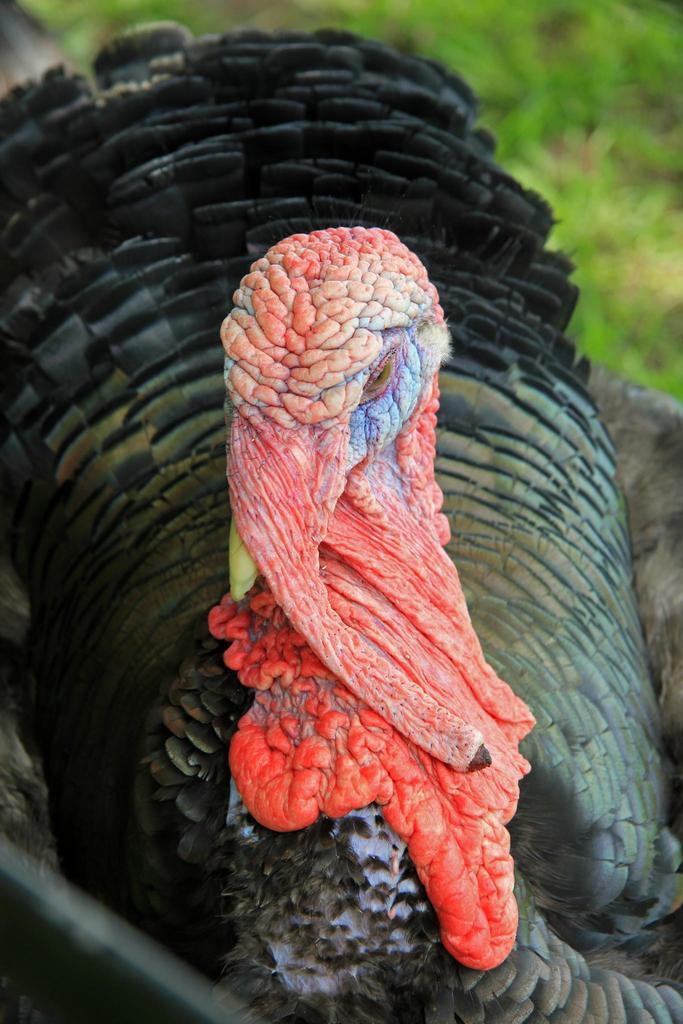What type of animal is in the foreground of the image? There is a domestic turkey in the foreground of the image. What can be seen in the background of the image? There is greenery visible in the background of the image. What type of marble is visible in the image? There is no marble present in the image. Is there a doctor attending to the turkey in the image? There is no doctor or any indication of medical attention in the image; it simply features a domestic turkey and greenery in the background. 